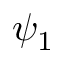Convert formula to latex. <formula><loc_0><loc_0><loc_500><loc_500>\psi _ { 1 }</formula> 